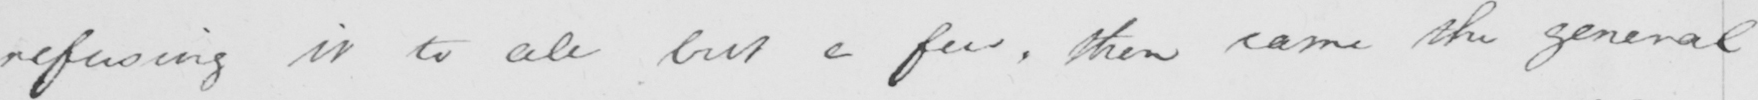Transcribe the text shown in this historical manuscript line. refusing it to all but a few , then came the general 